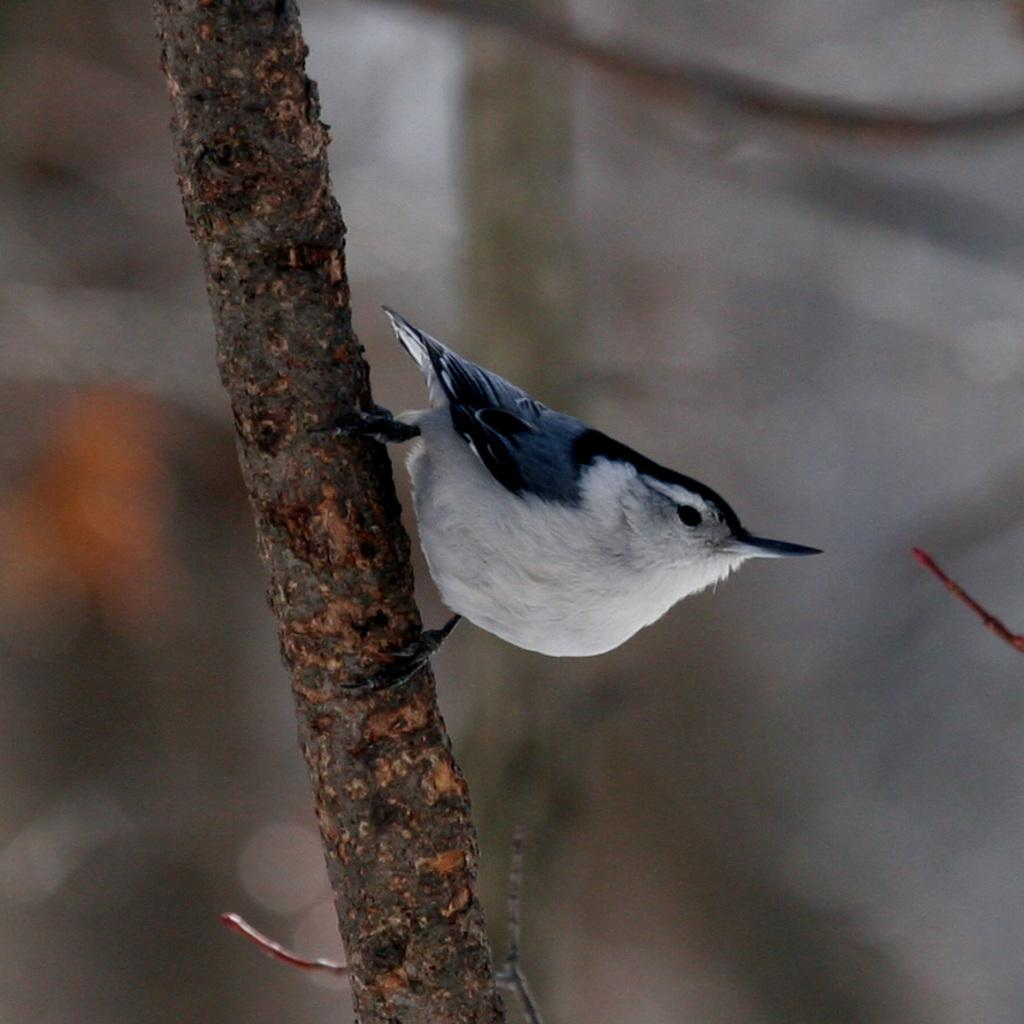What type of animal can be seen in the image? There is a bird in the image. Where is the bird located? The bird is on the bark. Can you describe the background of the image? The background of the image is blurred. What type of industry can be seen in the background of the image? There is no industry visible in the image; the background is blurred. Can you see the bird's nose in the image? Birds do not have noses like humans; they have a beak, which is visible in the image. 